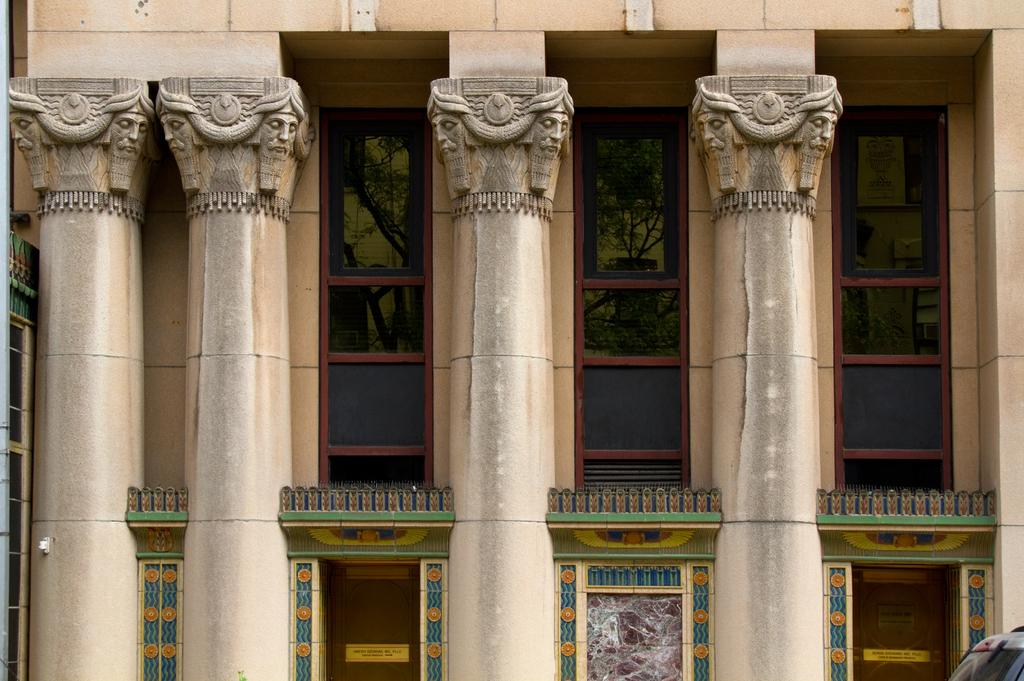What can be seen in the foreground of the image? In the foreground of the image, there are pillars, sculptures, and a fence. What type of artwork is present on a wall in the image? Wall paintings can be seen on a wall in the image. When was the image taken? The image was taken during the day. How many wrens are sitting on the fence in the image? There are no wrens present in the image; the fence is the only object mentioned in the foreground. What activity are the boys engaged in on the sidewalk in the image? There are no boys or sidewalks present in the image. 